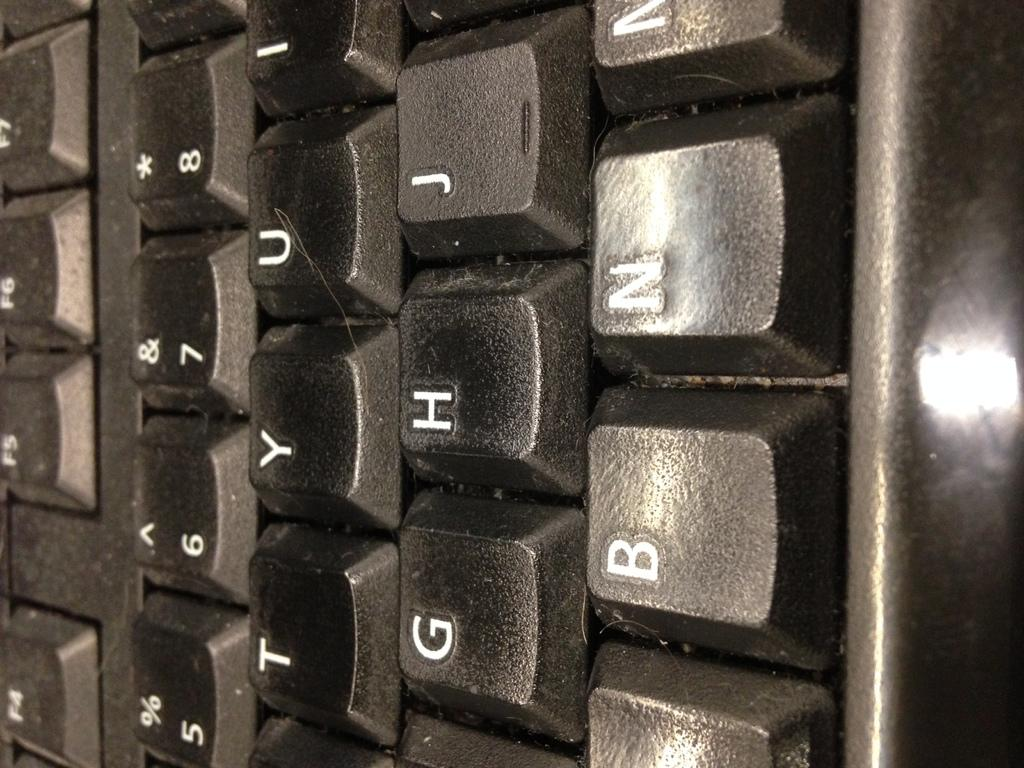What is the main object in the image? There is a keyboard in the image. What can be found on the keyboard? There are letters on the keyboard. What type of jelly is being used to hold the keyboard in place in the image? There is no jelly present in the image, and the keyboard is not being held in place by any jelly. 